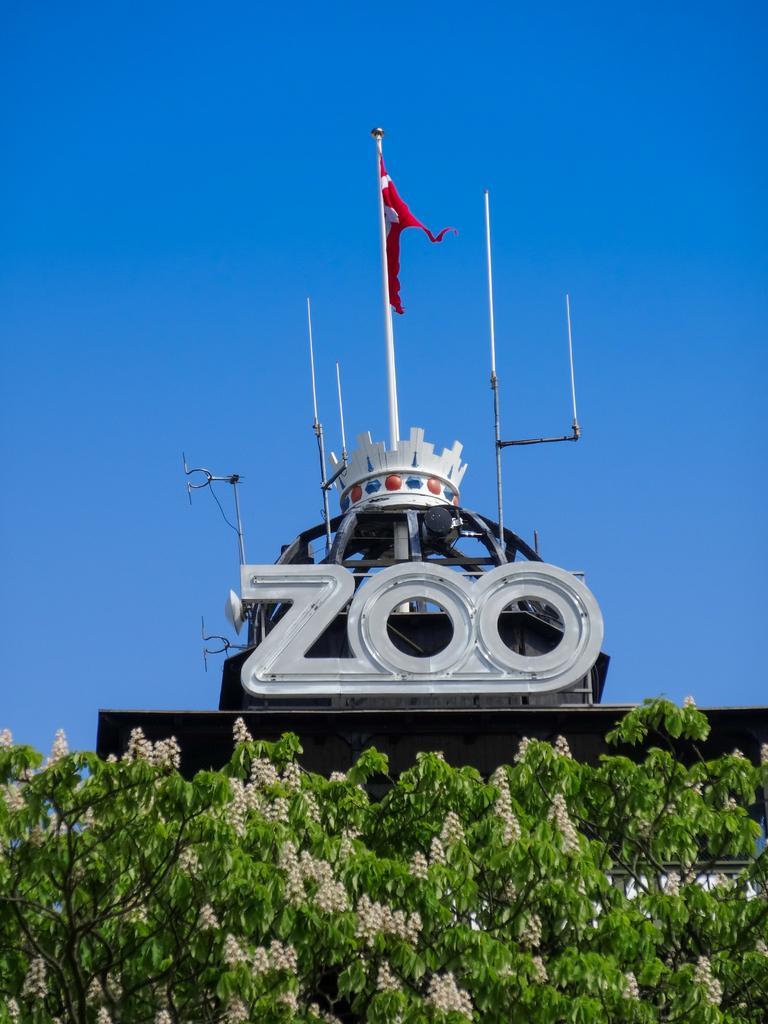What is located in the foreground of the picture? There is a tree in the foreground of the picture. What is the main feature in the center of the picture? There is a hoarding in the center of the picture. What can be seen above the hoarding? There are poles above the hoarding. What is attached to the poles? A flag is present on the poles. How would you describe the weather in the picture? The sky is clear and sunny in the picture. How many cans are visible on the tree in the image? There are no cans present on the tree in the image. Are there any cars parked near the hoarding in the image? There is no mention of cars in the provided facts, so we cannot determine if any are present in the image. What time is indicated by the clock on the hoarding in the image? There is no clock present on the hoarding in the image. 